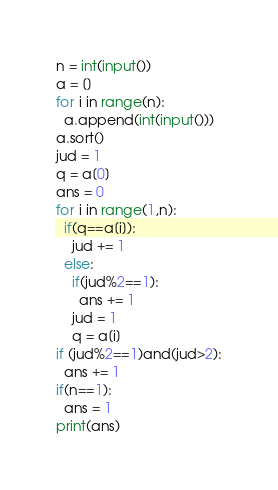Convert code to text. <code><loc_0><loc_0><loc_500><loc_500><_Python_>n = int(input())
a = []
for i in range(n):
  a.append(int(input()))
a.sort()
jud = 1
q = a[0]
ans = 0
for i in range(1,n):
  if(q==a[i]):
    jud += 1
  else: 
    if(jud%2==1):
      ans += 1
    jud = 1
    q = a[i]
if (jud%2==1)and(jud>2):
  ans += 1
if(n==1):
  ans = 1
print(ans)
</code> 